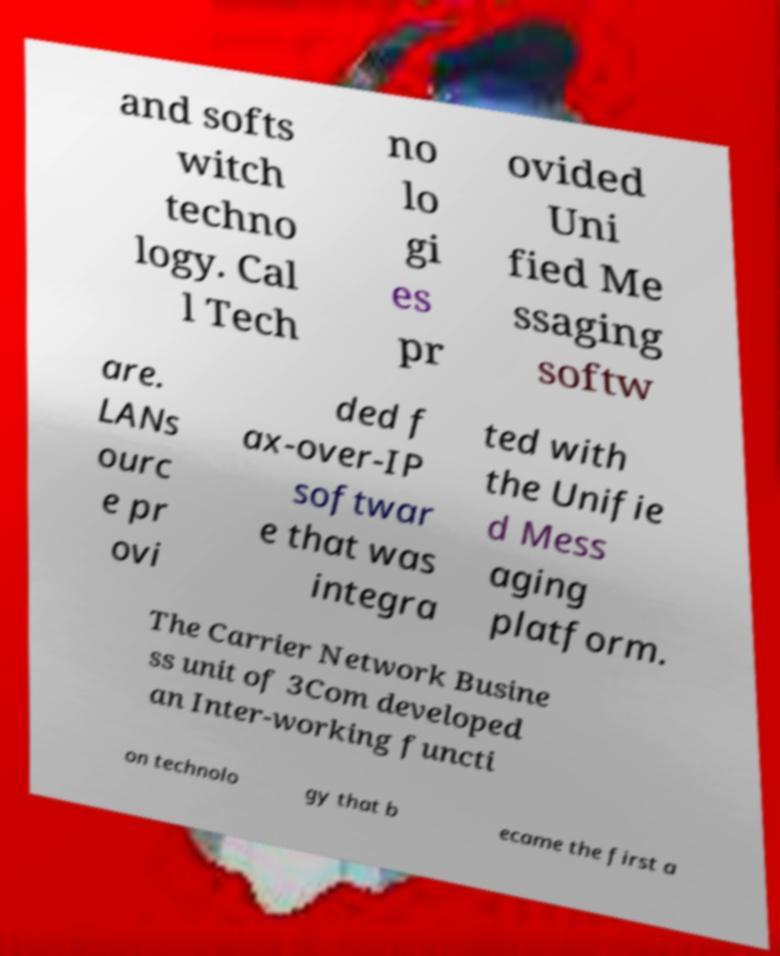What messages or text are displayed in this image? I need them in a readable, typed format. and softs witch techno logy. Cal l Tech no lo gi es pr ovided Uni fied Me ssaging softw are. LANs ourc e pr ovi ded f ax-over-IP softwar e that was integra ted with the Unifie d Mess aging platform. The Carrier Network Busine ss unit of 3Com developed an Inter-working functi on technolo gy that b ecame the first a 